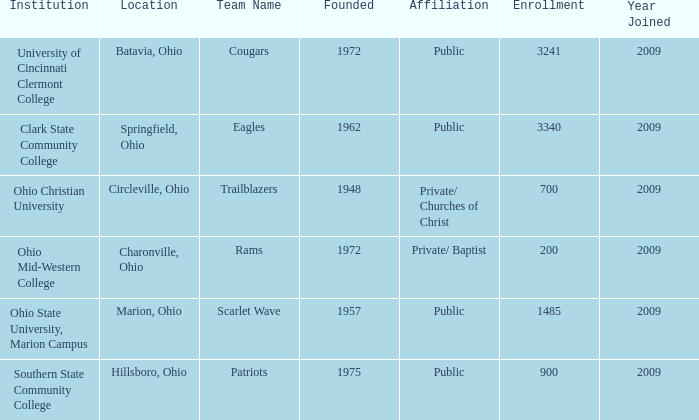What is the place that was established in 1957? Marion, Ohio. 